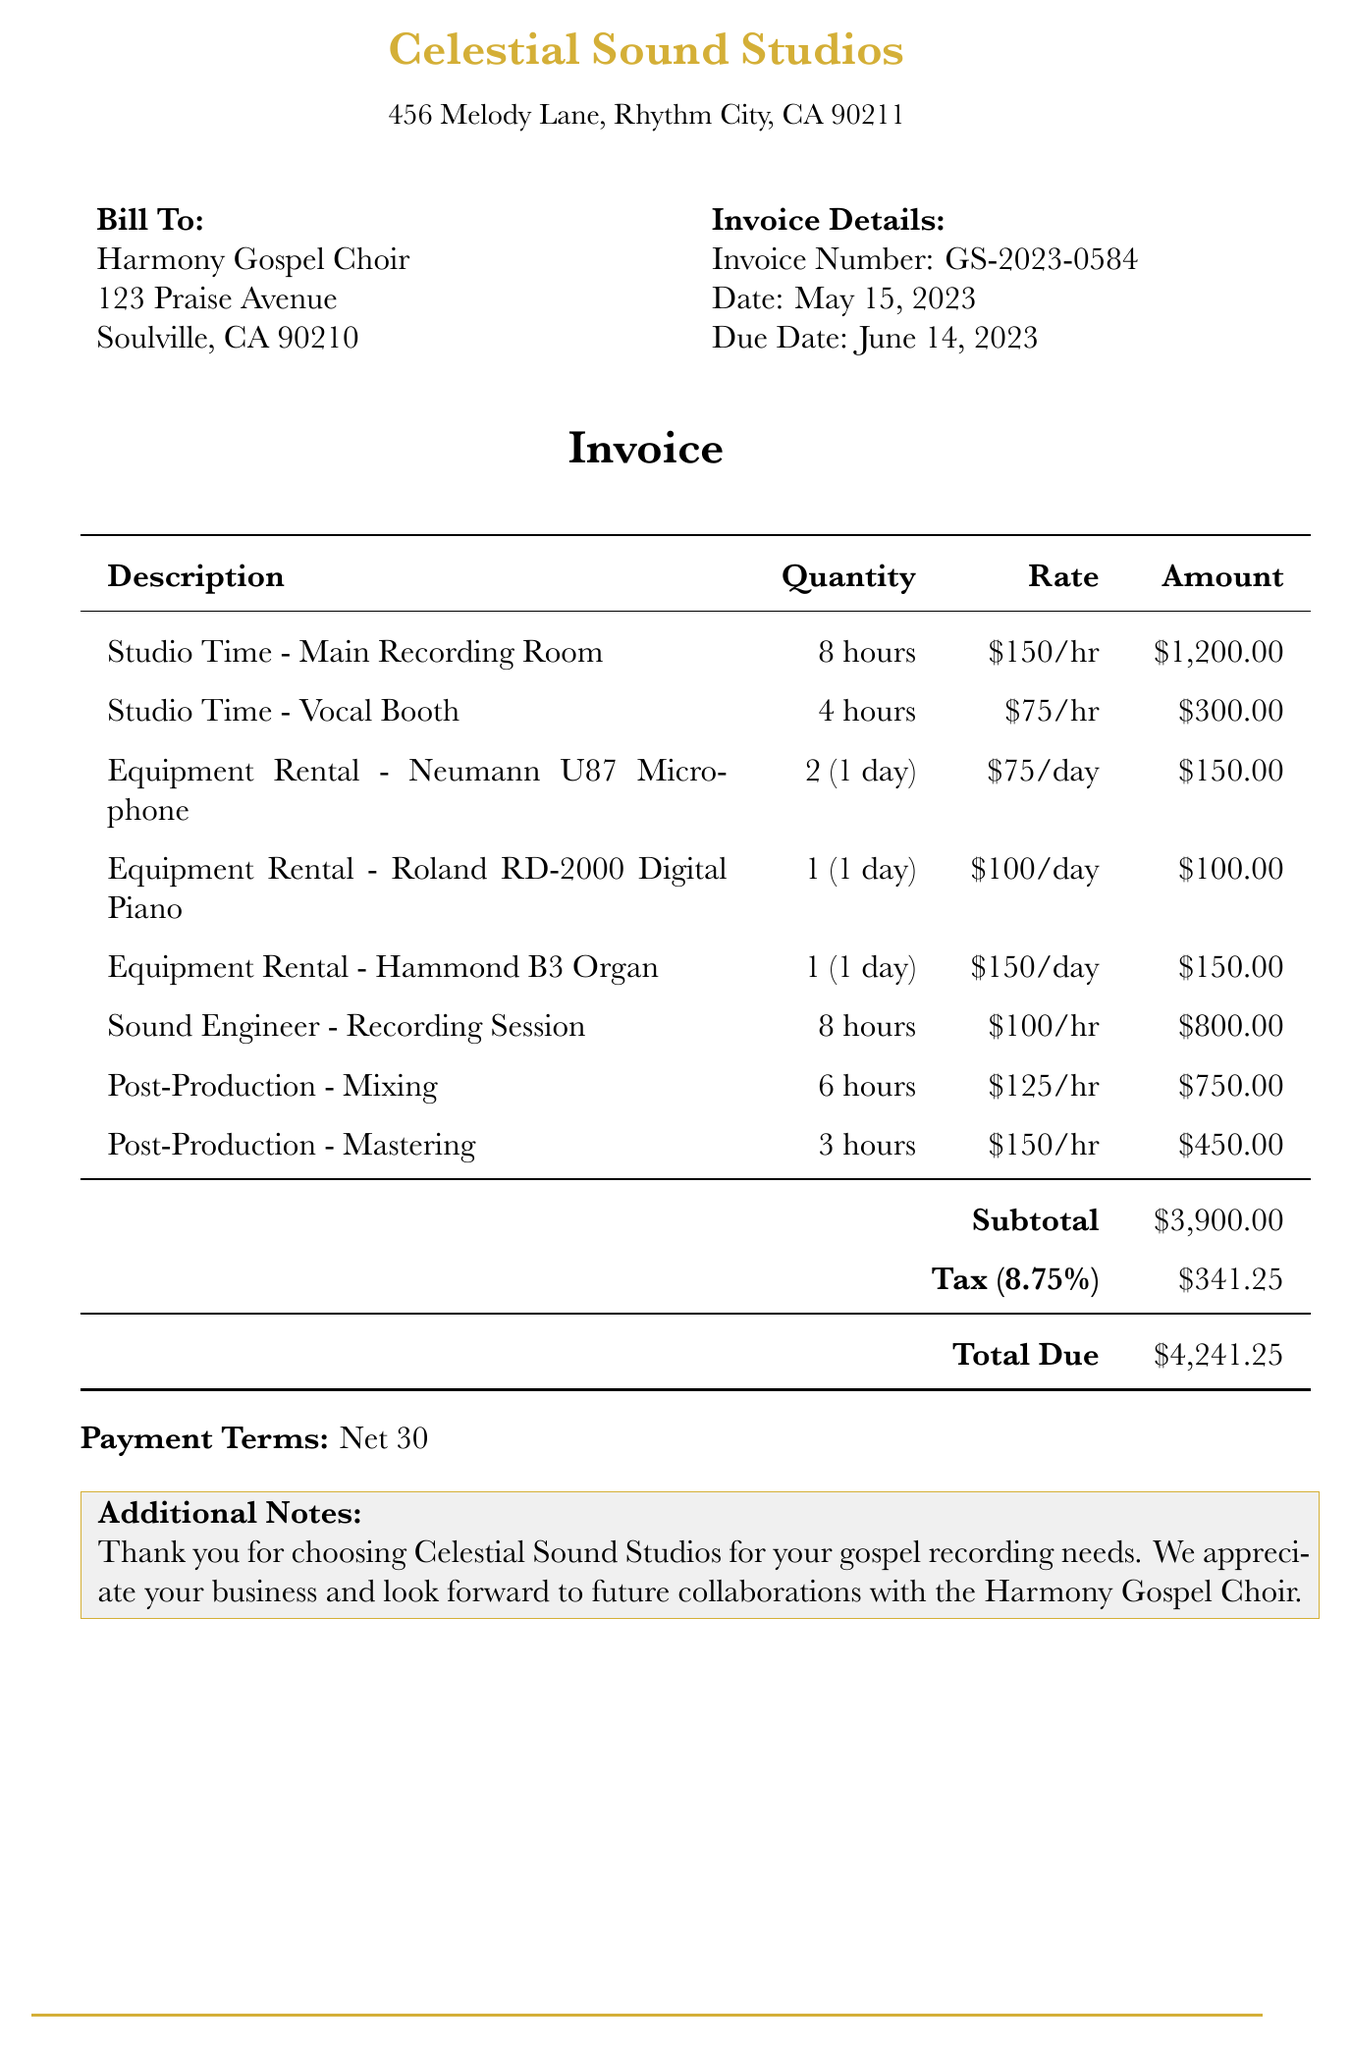What is the invoice number? The invoice number is listed directly in the document under Invoice Details.
Answer: GS-2023-0584 What is the due date for the invoice? The due date is specified in the invoice details section.
Answer: June 14, 2023 Who is the client for this invoice? The client's name is provided in the Bill To section.
Answer: Harmony Gospel Choir How many hours of Sound Engineer service was charged? The total hours for the Sound Engineer service are stated in the itemized list.
Answer: 8 hours What is the subtotal amount before tax? The subtotal is the total of all itemized services before tax, listed in the invoice.
Answer: $3,900.00 What is the tax rate applied in this invoice? The tax rate is mentioned in the tax section of the invoice.
Answer: 8.75% What is the total amount due? The total due is provided at the bottom of the invoice.
Answer: $4,241.25 What is the payment term stated in the invoice? The payment terms are mentioned at the end of the document.
Answer: Net 30 How many different pieces of equipment were rented? The document lists separate equipment rental items; counting them provides the total.
Answer: 3 